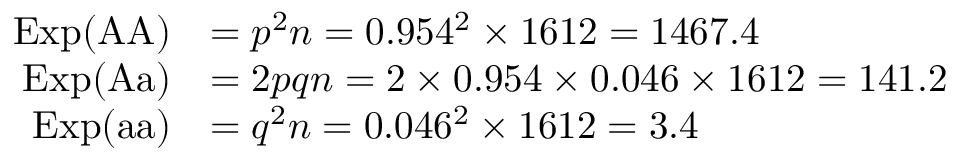Convert formula to latex. <formula><loc_0><loc_0><loc_500><loc_500>{ \begin{array} { r l } { E x p ( { A A } ) } & { = p ^ { 2 } n = 0 . 9 5 4 ^ { 2 } \times 1 6 1 2 = 1 4 6 7 . 4 } \\ { E x p ( { A a } ) } & { = 2 p q n = 2 \times 0 . 9 5 4 \times 0 . 0 4 6 \times 1 6 1 2 = 1 4 1 . 2 } \\ { E x p ( { a a } ) } & { = q ^ { 2 } n = 0 . 0 4 6 ^ { 2 } \times 1 6 1 2 = 3 . 4 } \end{array} }</formula> 